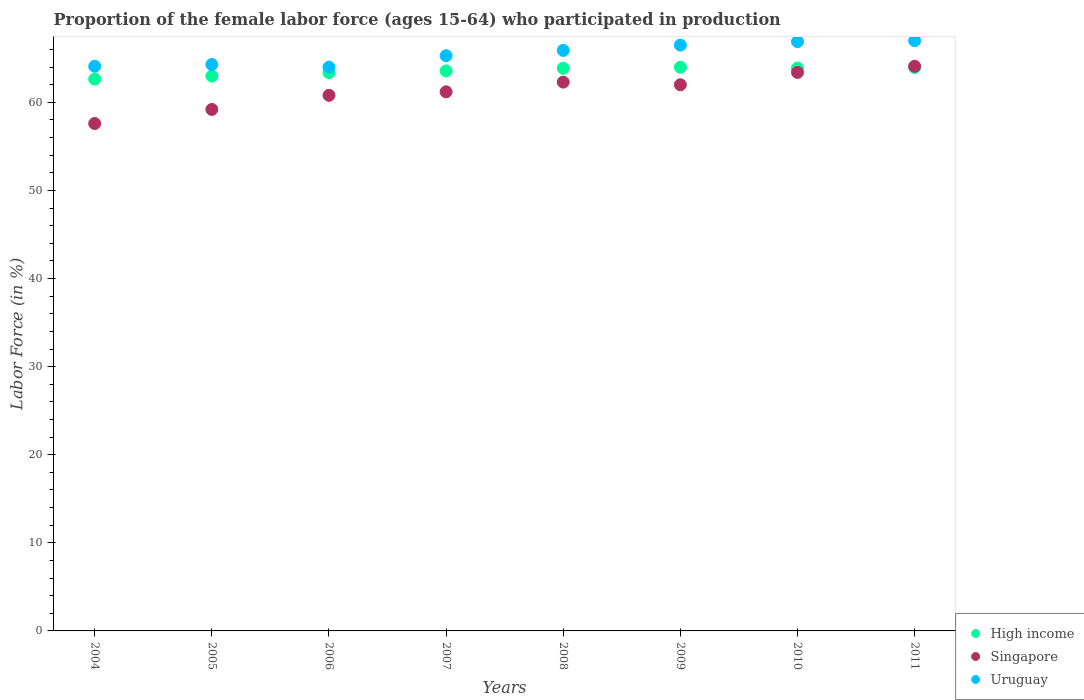Is the number of dotlines equal to the number of legend labels?
Ensure brevity in your answer.  Yes. What is the proportion of the female labor force who participated in production in High income in 2010?
Your response must be concise. 63.89. Across all years, what is the maximum proportion of the female labor force who participated in production in Singapore?
Keep it short and to the point. 64.1. Across all years, what is the minimum proportion of the female labor force who participated in production in High income?
Make the answer very short. 62.64. In which year was the proportion of the female labor force who participated in production in High income maximum?
Ensure brevity in your answer.  2009. What is the total proportion of the female labor force who participated in production in Singapore in the graph?
Offer a terse response. 490.6. What is the difference between the proportion of the female labor force who participated in production in Singapore in 2007 and that in 2010?
Keep it short and to the point. -2.2. What is the difference between the proportion of the female labor force who participated in production in High income in 2004 and the proportion of the female labor force who participated in production in Singapore in 2008?
Your response must be concise. 0.34. What is the average proportion of the female labor force who participated in production in High income per year?
Offer a terse response. 63.53. In the year 2006, what is the difference between the proportion of the female labor force who participated in production in High income and proportion of the female labor force who participated in production in Uruguay?
Your answer should be very brief. -0.62. In how many years, is the proportion of the female labor force who participated in production in Uruguay greater than 38 %?
Make the answer very short. 8. What is the ratio of the proportion of the female labor force who participated in production in Uruguay in 2005 to that in 2006?
Make the answer very short. 1. Is the difference between the proportion of the female labor force who participated in production in High income in 2006 and 2011 greater than the difference between the proportion of the female labor force who participated in production in Uruguay in 2006 and 2011?
Ensure brevity in your answer.  Yes. What is the difference between the highest and the second highest proportion of the female labor force who participated in production in Singapore?
Offer a terse response. 0.7. What is the difference between the highest and the lowest proportion of the female labor force who participated in production in High income?
Offer a terse response. 1.35. Is it the case that in every year, the sum of the proportion of the female labor force who participated in production in Uruguay and proportion of the female labor force who participated in production in Singapore  is greater than the proportion of the female labor force who participated in production in High income?
Your answer should be compact. Yes. Is the proportion of the female labor force who participated in production in Uruguay strictly greater than the proportion of the female labor force who participated in production in High income over the years?
Make the answer very short. Yes. How many years are there in the graph?
Offer a terse response. 8. Does the graph contain grids?
Your response must be concise. No. Where does the legend appear in the graph?
Provide a succinct answer. Bottom right. How many legend labels are there?
Provide a succinct answer. 3. How are the legend labels stacked?
Ensure brevity in your answer.  Vertical. What is the title of the graph?
Make the answer very short. Proportion of the female labor force (ages 15-64) who participated in production. Does "American Samoa" appear as one of the legend labels in the graph?
Provide a short and direct response. No. What is the label or title of the X-axis?
Your answer should be compact. Years. What is the Labor Force (in %) in High income in 2004?
Offer a terse response. 62.64. What is the Labor Force (in %) in Singapore in 2004?
Your answer should be compact. 57.6. What is the Labor Force (in %) of Uruguay in 2004?
Ensure brevity in your answer.  64.1. What is the Labor Force (in %) in High income in 2005?
Offer a terse response. 62.99. What is the Labor Force (in %) in Singapore in 2005?
Provide a succinct answer. 59.2. What is the Labor Force (in %) of Uruguay in 2005?
Offer a terse response. 64.3. What is the Labor Force (in %) of High income in 2006?
Your response must be concise. 63.38. What is the Labor Force (in %) of Singapore in 2006?
Your answer should be very brief. 60.8. What is the Labor Force (in %) of High income in 2007?
Provide a succinct answer. 63.57. What is the Labor Force (in %) in Singapore in 2007?
Provide a short and direct response. 61.2. What is the Labor Force (in %) of Uruguay in 2007?
Your answer should be very brief. 65.3. What is the Labor Force (in %) of High income in 2008?
Give a very brief answer. 63.87. What is the Labor Force (in %) of Singapore in 2008?
Keep it short and to the point. 62.3. What is the Labor Force (in %) of Uruguay in 2008?
Offer a very short reply. 65.9. What is the Labor Force (in %) in High income in 2009?
Ensure brevity in your answer.  63.99. What is the Labor Force (in %) of Uruguay in 2009?
Keep it short and to the point. 66.5. What is the Labor Force (in %) in High income in 2010?
Your response must be concise. 63.89. What is the Labor Force (in %) in Singapore in 2010?
Offer a very short reply. 63.4. What is the Labor Force (in %) of Uruguay in 2010?
Provide a short and direct response. 66.9. What is the Labor Force (in %) in High income in 2011?
Offer a very short reply. 63.95. What is the Labor Force (in %) of Singapore in 2011?
Your answer should be very brief. 64.1. What is the Labor Force (in %) of Uruguay in 2011?
Offer a very short reply. 67. Across all years, what is the maximum Labor Force (in %) in High income?
Your answer should be compact. 63.99. Across all years, what is the maximum Labor Force (in %) of Singapore?
Your response must be concise. 64.1. Across all years, what is the minimum Labor Force (in %) in High income?
Provide a succinct answer. 62.64. Across all years, what is the minimum Labor Force (in %) in Singapore?
Provide a succinct answer. 57.6. What is the total Labor Force (in %) in High income in the graph?
Your answer should be compact. 508.28. What is the total Labor Force (in %) of Singapore in the graph?
Give a very brief answer. 490.6. What is the total Labor Force (in %) in Uruguay in the graph?
Ensure brevity in your answer.  524. What is the difference between the Labor Force (in %) in High income in 2004 and that in 2005?
Offer a very short reply. -0.35. What is the difference between the Labor Force (in %) in Uruguay in 2004 and that in 2005?
Provide a succinct answer. -0.2. What is the difference between the Labor Force (in %) of High income in 2004 and that in 2006?
Make the answer very short. -0.74. What is the difference between the Labor Force (in %) in Uruguay in 2004 and that in 2006?
Offer a terse response. 0.1. What is the difference between the Labor Force (in %) in High income in 2004 and that in 2007?
Your answer should be very brief. -0.93. What is the difference between the Labor Force (in %) of Uruguay in 2004 and that in 2007?
Provide a succinct answer. -1.2. What is the difference between the Labor Force (in %) in High income in 2004 and that in 2008?
Your response must be concise. -1.23. What is the difference between the Labor Force (in %) of High income in 2004 and that in 2009?
Your answer should be compact. -1.35. What is the difference between the Labor Force (in %) in Singapore in 2004 and that in 2009?
Give a very brief answer. -4.4. What is the difference between the Labor Force (in %) in Uruguay in 2004 and that in 2009?
Your response must be concise. -2.4. What is the difference between the Labor Force (in %) of High income in 2004 and that in 2010?
Make the answer very short. -1.25. What is the difference between the Labor Force (in %) in High income in 2004 and that in 2011?
Ensure brevity in your answer.  -1.31. What is the difference between the Labor Force (in %) of Uruguay in 2004 and that in 2011?
Your answer should be compact. -2.9. What is the difference between the Labor Force (in %) of High income in 2005 and that in 2006?
Give a very brief answer. -0.4. What is the difference between the Labor Force (in %) in Uruguay in 2005 and that in 2006?
Your answer should be very brief. 0.3. What is the difference between the Labor Force (in %) in High income in 2005 and that in 2007?
Keep it short and to the point. -0.58. What is the difference between the Labor Force (in %) in Uruguay in 2005 and that in 2007?
Offer a terse response. -1. What is the difference between the Labor Force (in %) of High income in 2005 and that in 2008?
Your response must be concise. -0.88. What is the difference between the Labor Force (in %) of Uruguay in 2005 and that in 2008?
Ensure brevity in your answer.  -1.6. What is the difference between the Labor Force (in %) of High income in 2005 and that in 2009?
Your answer should be very brief. -1. What is the difference between the Labor Force (in %) in High income in 2005 and that in 2010?
Your answer should be very brief. -0.9. What is the difference between the Labor Force (in %) of High income in 2005 and that in 2011?
Provide a short and direct response. -0.97. What is the difference between the Labor Force (in %) in Uruguay in 2005 and that in 2011?
Give a very brief answer. -2.7. What is the difference between the Labor Force (in %) in High income in 2006 and that in 2007?
Your answer should be very brief. -0.19. What is the difference between the Labor Force (in %) of Singapore in 2006 and that in 2007?
Ensure brevity in your answer.  -0.4. What is the difference between the Labor Force (in %) in Uruguay in 2006 and that in 2007?
Your answer should be very brief. -1.3. What is the difference between the Labor Force (in %) in High income in 2006 and that in 2008?
Make the answer very short. -0.49. What is the difference between the Labor Force (in %) of Singapore in 2006 and that in 2008?
Make the answer very short. -1.5. What is the difference between the Labor Force (in %) in Uruguay in 2006 and that in 2008?
Offer a very short reply. -1.9. What is the difference between the Labor Force (in %) of High income in 2006 and that in 2009?
Offer a very short reply. -0.61. What is the difference between the Labor Force (in %) in Singapore in 2006 and that in 2009?
Provide a succinct answer. -1.2. What is the difference between the Labor Force (in %) of Uruguay in 2006 and that in 2009?
Your answer should be very brief. -2.5. What is the difference between the Labor Force (in %) in High income in 2006 and that in 2010?
Ensure brevity in your answer.  -0.51. What is the difference between the Labor Force (in %) in Singapore in 2006 and that in 2010?
Offer a terse response. -2.6. What is the difference between the Labor Force (in %) in High income in 2006 and that in 2011?
Your answer should be very brief. -0.57. What is the difference between the Labor Force (in %) in Uruguay in 2006 and that in 2011?
Offer a very short reply. -3. What is the difference between the Labor Force (in %) of High income in 2007 and that in 2008?
Ensure brevity in your answer.  -0.3. What is the difference between the Labor Force (in %) of Uruguay in 2007 and that in 2008?
Offer a terse response. -0.6. What is the difference between the Labor Force (in %) in High income in 2007 and that in 2009?
Keep it short and to the point. -0.42. What is the difference between the Labor Force (in %) of Singapore in 2007 and that in 2009?
Ensure brevity in your answer.  -0.8. What is the difference between the Labor Force (in %) of High income in 2007 and that in 2010?
Keep it short and to the point. -0.32. What is the difference between the Labor Force (in %) in High income in 2007 and that in 2011?
Keep it short and to the point. -0.38. What is the difference between the Labor Force (in %) of Uruguay in 2007 and that in 2011?
Keep it short and to the point. -1.7. What is the difference between the Labor Force (in %) of High income in 2008 and that in 2009?
Your answer should be very brief. -0.12. What is the difference between the Labor Force (in %) in Singapore in 2008 and that in 2009?
Offer a very short reply. 0.3. What is the difference between the Labor Force (in %) of High income in 2008 and that in 2010?
Your answer should be very brief. -0.02. What is the difference between the Labor Force (in %) in Uruguay in 2008 and that in 2010?
Offer a terse response. -1. What is the difference between the Labor Force (in %) in High income in 2008 and that in 2011?
Keep it short and to the point. -0.09. What is the difference between the Labor Force (in %) of Singapore in 2008 and that in 2011?
Keep it short and to the point. -1.8. What is the difference between the Labor Force (in %) in Uruguay in 2008 and that in 2011?
Provide a short and direct response. -1.1. What is the difference between the Labor Force (in %) in High income in 2009 and that in 2010?
Offer a terse response. 0.1. What is the difference between the Labor Force (in %) in Singapore in 2009 and that in 2010?
Give a very brief answer. -1.4. What is the difference between the Labor Force (in %) of High income in 2009 and that in 2011?
Provide a succinct answer. 0.04. What is the difference between the Labor Force (in %) of Singapore in 2009 and that in 2011?
Give a very brief answer. -2.1. What is the difference between the Labor Force (in %) in Uruguay in 2009 and that in 2011?
Your answer should be very brief. -0.5. What is the difference between the Labor Force (in %) of High income in 2010 and that in 2011?
Your response must be concise. -0.06. What is the difference between the Labor Force (in %) in Uruguay in 2010 and that in 2011?
Offer a terse response. -0.1. What is the difference between the Labor Force (in %) in High income in 2004 and the Labor Force (in %) in Singapore in 2005?
Provide a succinct answer. 3.44. What is the difference between the Labor Force (in %) in High income in 2004 and the Labor Force (in %) in Uruguay in 2005?
Provide a short and direct response. -1.66. What is the difference between the Labor Force (in %) of High income in 2004 and the Labor Force (in %) of Singapore in 2006?
Give a very brief answer. 1.84. What is the difference between the Labor Force (in %) of High income in 2004 and the Labor Force (in %) of Uruguay in 2006?
Provide a short and direct response. -1.36. What is the difference between the Labor Force (in %) in Singapore in 2004 and the Labor Force (in %) in Uruguay in 2006?
Provide a short and direct response. -6.4. What is the difference between the Labor Force (in %) in High income in 2004 and the Labor Force (in %) in Singapore in 2007?
Give a very brief answer. 1.44. What is the difference between the Labor Force (in %) in High income in 2004 and the Labor Force (in %) in Uruguay in 2007?
Keep it short and to the point. -2.66. What is the difference between the Labor Force (in %) of Singapore in 2004 and the Labor Force (in %) of Uruguay in 2007?
Offer a terse response. -7.7. What is the difference between the Labor Force (in %) of High income in 2004 and the Labor Force (in %) of Singapore in 2008?
Keep it short and to the point. 0.34. What is the difference between the Labor Force (in %) in High income in 2004 and the Labor Force (in %) in Uruguay in 2008?
Offer a very short reply. -3.26. What is the difference between the Labor Force (in %) of Singapore in 2004 and the Labor Force (in %) of Uruguay in 2008?
Your answer should be very brief. -8.3. What is the difference between the Labor Force (in %) in High income in 2004 and the Labor Force (in %) in Singapore in 2009?
Ensure brevity in your answer.  0.64. What is the difference between the Labor Force (in %) in High income in 2004 and the Labor Force (in %) in Uruguay in 2009?
Provide a short and direct response. -3.86. What is the difference between the Labor Force (in %) of Singapore in 2004 and the Labor Force (in %) of Uruguay in 2009?
Give a very brief answer. -8.9. What is the difference between the Labor Force (in %) in High income in 2004 and the Labor Force (in %) in Singapore in 2010?
Make the answer very short. -0.76. What is the difference between the Labor Force (in %) in High income in 2004 and the Labor Force (in %) in Uruguay in 2010?
Offer a terse response. -4.26. What is the difference between the Labor Force (in %) of High income in 2004 and the Labor Force (in %) of Singapore in 2011?
Offer a terse response. -1.46. What is the difference between the Labor Force (in %) of High income in 2004 and the Labor Force (in %) of Uruguay in 2011?
Ensure brevity in your answer.  -4.36. What is the difference between the Labor Force (in %) in Singapore in 2004 and the Labor Force (in %) in Uruguay in 2011?
Offer a very short reply. -9.4. What is the difference between the Labor Force (in %) of High income in 2005 and the Labor Force (in %) of Singapore in 2006?
Your answer should be compact. 2.19. What is the difference between the Labor Force (in %) of High income in 2005 and the Labor Force (in %) of Uruguay in 2006?
Make the answer very short. -1.01. What is the difference between the Labor Force (in %) in High income in 2005 and the Labor Force (in %) in Singapore in 2007?
Give a very brief answer. 1.79. What is the difference between the Labor Force (in %) in High income in 2005 and the Labor Force (in %) in Uruguay in 2007?
Provide a short and direct response. -2.31. What is the difference between the Labor Force (in %) in Singapore in 2005 and the Labor Force (in %) in Uruguay in 2007?
Provide a succinct answer. -6.1. What is the difference between the Labor Force (in %) in High income in 2005 and the Labor Force (in %) in Singapore in 2008?
Offer a terse response. 0.69. What is the difference between the Labor Force (in %) of High income in 2005 and the Labor Force (in %) of Uruguay in 2008?
Provide a short and direct response. -2.91. What is the difference between the Labor Force (in %) in High income in 2005 and the Labor Force (in %) in Uruguay in 2009?
Give a very brief answer. -3.51. What is the difference between the Labor Force (in %) of High income in 2005 and the Labor Force (in %) of Singapore in 2010?
Your answer should be very brief. -0.41. What is the difference between the Labor Force (in %) in High income in 2005 and the Labor Force (in %) in Uruguay in 2010?
Provide a succinct answer. -3.91. What is the difference between the Labor Force (in %) of Singapore in 2005 and the Labor Force (in %) of Uruguay in 2010?
Give a very brief answer. -7.7. What is the difference between the Labor Force (in %) in High income in 2005 and the Labor Force (in %) in Singapore in 2011?
Make the answer very short. -1.11. What is the difference between the Labor Force (in %) of High income in 2005 and the Labor Force (in %) of Uruguay in 2011?
Your answer should be compact. -4.01. What is the difference between the Labor Force (in %) in High income in 2006 and the Labor Force (in %) in Singapore in 2007?
Your response must be concise. 2.18. What is the difference between the Labor Force (in %) in High income in 2006 and the Labor Force (in %) in Uruguay in 2007?
Your answer should be very brief. -1.92. What is the difference between the Labor Force (in %) in Singapore in 2006 and the Labor Force (in %) in Uruguay in 2007?
Give a very brief answer. -4.5. What is the difference between the Labor Force (in %) in High income in 2006 and the Labor Force (in %) in Singapore in 2008?
Provide a short and direct response. 1.08. What is the difference between the Labor Force (in %) in High income in 2006 and the Labor Force (in %) in Uruguay in 2008?
Make the answer very short. -2.52. What is the difference between the Labor Force (in %) of Singapore in 2006 and the Labor Force (in %) of Uruguay in 2008?
Your response must be concise. -5.1. What is the difference between the Labor Force (in %) in High income in 2006 and the Labor Force (in %) in Singapore in 2009?
Make the answer very short. 1.38. What is the difference between the Labor Force (in %) of High income in 2006 and the Labor Force (in %) of Uruguay in 2009?
Your answer should be very brief. -3.12. What is the difference between the Labor Force (in %) of High income in 2006 and the Labor Force (in %) of Singapore in 2010?
Your answer should be very brief. -0.02. What is the difference between the Labor Force (in %) in High income in 2006 and the Labor Force (in %) in Uruguay in 2010?
Provide a short and direct response. -3.52. What is the difference between the Labor Force (in %) in High income in 2006 and the Labor Force (in %) in Singapore in 2011?
Ensure brevity in your answer.  -0.72. What is the difference between the Labor Force (in %) of High income in 2006 and the Labor Force (in %) of Uruguay in 2011?
Your answer should be very brief. -3.62. What is the difference between the Labor Force (in %) in Singapore in 2006 and the Labor Force (in %) in Uruguay in 2011?
Your answer should be compact. -6.2. What is the difference between the Labor Force (in %) in High income in 2007 and the Labor Force (in %) in Singapore in 2008?
Provide a short and direct response. 1.27. What is the difference between the Labor Force (in %) in High income in 2007 and the Labor Force (in %) in Uruguay in 2008?
Offer a terse response. -2.33. What is the difference between the Labor Force (in %) of Singapore in 2007 and the Labor Force (in %) of Uruguay in 2008?
Your answer should be compact. -4.7. What is the difference between the Labor Force (in %) of High income in 2007 and the Labor Force (in %) of Singapore in 2009?
Your answer should be very brief. 1.57. What is the difference between the Labor Force (in %) of High income in 2007 and the Labor Force (in %) of Uruguay in 2009?
Provide a short and direct response. -2.93. What is the difference between the Labor Force (in %) in High income in 2007 and the Labor Force (in %) in Singapore in 2010?
Your answer should be very brief. 0.17. What is the difference between the Labor Force (in %) in High income in 2007 and the Labor Force (in %) in Uruguay in 2010?
Provide a succinct answer. -3.33. What is the difference between the Labor Force (in %) of Singapore in 2007 and the Labor Force (in %) of Uruguay in 2010?
Your answer should be compact. -5.7. What is the difference between the Labor Force (in %) of High income in 2007 and the Labor Force (in %) of Singapore in 2011?
Give a very brief answer. -0.53. What is the difference between the Labor Force (in %) of High income in 2007 and the Labor Force (in %) of Uruguay in 2011?
Offer a very short reply. -3.43. What is the difference between the Labor Force (in %) of High income in 2008 and the Labor Force (in %) of Singapore in 2009?
Make the answer very short. 1.87. What is the difference between the Labor Force (in %) of High income in 2008 and the Labor Force (in %) of Uruguay in 2009?
Give a very brief answer. -2.63. What is the difference between the Labor Force (in %) of Singapore in 2008 and the Labor Force (in %) of Uruguay in 2009?
Keep it short and to the point. -4.2. What is the difference between the Labor Force (in %) of High income in 2008 and the Labor Force (in %) of Singapore in 2010?
Offer a very short reply. 0.47. What is the difference between the Labor Force (in %) of High income in 2008 and the Labor Force (in %) of Uruguay in 2010?
Give a very brief answer. -3.03. What is the difference between the Labor Force (in %) in Singapore in 2008 and the Labor Force (in %) in Uruguay in 2010?
Your response must be concise. -4.6. What is the difference between the Labor Force (in %) of High income in 2008 and the Labor Force (in %) of Singapore in 2011?
Keep it short and to the point. -0.23. What is the difference between the Labor Force (in %) of High income in 2008 and the Labor Force (in %) of Uruguay in 2011?
Provide a succinct answer. -3.13. What is the difference between the Labor Force (in %) of Singapore in 2008 and the Labor Force (in %) of Uruguay in 2011?
Provide a short and direct response. -4.7. What is the difference between the Labor Force (in %) of High income in 2009 and the Labor Force (in %) of Singapore in 2010?
Offer a very short reply. 0.59. What is the difference between the Labor Force (in %) of High income in 2009 and the Labor Force (in %) of Uruguay in 2010?
Your answer should be very brief. -2.91. What is the difference between the Labor Force (in %) in Singapore in 2009 and the Labor Force (in %) in Uruguay in 2010?
Keep it short and to the point. -4.9. What is the difference between the Labor Force (in %) in High income in 2009 and the Labor Force (in %) in Singapore in 2011?
Your answer should be very brief. -0.11. What is the difference between the Labor Force (in %) in High income in 2009 and the Labor Force (in %) in Uruguay in 2011?
Offer a very short reply. -3.01. What is the difference between the Labor Force (in %) in High income in 2010 and the Labor Force (in %) in Singapore in 2011?
Your answer should be very brief. -0.21. What is the difference between the Labor Force (in %) of High income in 2010 and the Labor Force (in %) of Uruguay in 2011?
Provide a succinct answer. -3.11. What is the average Labor Force (in %) in High income per year?
Provide a short and direct response. 63.53. What is the average Labor Force (in %) in Singapore per year?
Provide a short and direct response. 61.33. What is the average Labor Force (in %) of Uruguay per year?
Keep it short and to the point. 65.5. In the year 2004, what is the difference between the Labor Force (in %) in High income and Labor Force (in %) in Singapore?
Ensure brevity in your answer.  5.04. In the year 2004, what is the difference between the Labor Force (in %) in High income and Labor Force (in %) in Uruguay?
Offer a very short reply. -1.46. In the year 2004, what is the difference between the Labor Force (in %) of Singapore and Labor Force (in %) of Uruguay?
Offer a terse response. -6.5. In the year 2005, what is the difference between the Labor Force (in %) in High income and Labor Force (in %) in Singapore?
Your answer should be compact. 3.79. In the year 2005, what is the difference between the Labor Force (in %) in High income and Labor Force (in %) in Uruguay?
Make the answer very short. -1.31. In the year 2005, what is the difference between the Labor Force (in %) of Singapore and Labor Force (in %) of Uruguay?
Provide a succinct answer. -5.1. In the year 2006, what is the difference between the Labor Force (in %) in High income and Labor Force (in %) in Singapore?
Your response must be concise. 2.58. In the year 2006, what is the difference between the Labor Force (in %) in High income and Labor Force (in %) in Uruguay?
Your response must be concise. -0.62. In the year 2007, what is the difference between the Labor Force (in %) in High income and Labor Force (in %) in Singapore?
Your answer should be compact. 2.37. In the year 2007, what is the difference between the Labor Force (in %) of High income and Labor Force (in %) of Uruguay?
Your answer should be very brief. -1.73. In the year 2007, what is the difference between the Labor Force (in %) of Singapore and Labor Force (in %) of Uruguay?
Your answer should be very brief. -4.1. In the year 2008, what is the difference between the Labor Force (in %) in High income and Labor Force (in %) in Singapore?
Make the answer very short. 1.57. In the year 2008, what is the difference between the Labor Force (in %) in High income and Labor Force (in %) in Uruguay?
Offer a very short reply. -2.03. In the year 2008, what is the difference between the Labor Force (in %) in Singapore and Labor Force (in %) in Uruguay?
Your response must be concise. -3.6. In the year 2009, what is the difference between the Labor Force (in %) of High income and Labor Force (in %) of Singapore?
Keep it short and to the point. 1.99. In the year 2009, what is the difference between the Labor Force (in %) in High income and Labor Force (in %) in Uruguay?
Your answer should be very brief. -2.51. In the year 2009, what is the difference between the Labor Force (in %) of Singapore and Labor Force (in %) of Uruguay?
Make the answer very short. -4.5. In the year 2010, what is the difference between the Labor Force (in %) in High income and Labor Force (in %) in Singapore?
Provide a short and direct response. 0.49. In the year 2010, what is the difference between the Labor Force (in %) of High income and Labor Force (in %) of Uruguay?
Ensure brevity in your answer.  -3.01. In the year 2011, what is the difference between the Labor Force (in %) in High income and Labor Force (in %) in Singapore?
Your answer should be very brief. -0.15. In the year 2011, what is the difference between the Labor Force (in %) of High income and Labor Force (in %) of Uruguay?
Your answer should be very brief. -3.05. What is the ratio of the Labor Force (in %) in Singapore in 2004 to that in 2005?
Your answer should be compact. 0.97. What is the ratio of the Labor Force (in %) of High income in 2004 to that in 2006?
Your response must be concise. 0.99. What is the ratio of the Labor Force (in %) in Uruguay in 2004 to that in 2006?
Offer a terse response. 1. What is the ratio of the Labor Force (in %) in High income in 2004 to that in 2007?
Keep it short and to the point. 0.99. What is the ratio of the Labor Force (in %) in Singapore in 2004 to that in 2007?
Your answer should be compact. 0.94. What is the ratio of the Labor Force (in %) of Uruguay in 2004 to that in 2007?
Make the answer very short. 0.98. What is the ratio of the Labor Force (in %) in High income in 2004 to that in 2008?
Keep it short and to the point. 0.98. What is the ratio of the Labor Force (in %) of Singapore in 2004 to that in 2008?
Ensure brevity in your answer.  0.92. What is the ratio of the Labor Force (in %) in Uruguay in 2004 to that in 2008?
Your answer should be compact. 0.97. What is the ratio of the Labor Force (in %) of High income in 2004 to that in 2009?
Provide a succinct answer. 0.98. What is the ratio of the Labor Force (in %) in Singapore in 2004 to that in 2009?
Offer a terse response. 0.93. What is the ratio of the Labor Force (in %) in Uruguay in 2004 to that in 2009?
Give a very brief answer. 0.96. What is the ratio of the Labor Force (in %) in High income in 2004 to that in 2010?
Ensure brevity in your answer.  0.98. What is the ratio of the Labor Force (in %) in Singapore in 2004 to that in 2010?
Offer a terse response. 0.91. What is the ratio of the Labor Force (in %) in Uruguay in 2004 to that in 2010?
Ensure brevity in your answer.  0.96. What is the ratio of the Labor Force (in %) in High income in 2004 to that in 2011?
Your answer should be very brief. 0.98. What is the ratio of the Labor Force (in %) in Singapore in 2004 to that in 2011?
Your response must be concise. 0.9. What is the ratio of the Labor Force (in %) in Uruguay in 2004 to that in 2011?
Give a very brief answer. 0.96. What is the ratio of the Labor Force (in %) of High income in 2005 to that in 2006?
Offer a very short reply. 0.99. What is the ratio of the Labor Force (in %) of Singapore in 2005 to that in 2006?
Your answer should be very brief. 0.97. What is the ratio of the Labor Force (in %) of High income in 2005 to that in 2007?
Give a very brief answer. 0.99. What is the ratio of the Labor Force (in %) of Singapore in 2005 to that in 2007?
Give a very brief answer. 0.97. What is the ratio of the Labor Force (in %) of Uruguay in 2005 to that in 2007?
Offer a terse response. 0.98. What is the ratio of the Labor Force (in %) of High income in 2005 to that in 2008?
Provide a short and direct response. 0.99. What is the ratio of the Labor Force (in %) of Singapore in 2005 to that in 2008?
Give a very brief answer. 0.95. What is the ratio of the Labor Force (in %) of Uruguay in 2005 to that in 2008?
Keep it short and to the point. 0.98. What is the ratio of the Labor Force (in %) in High income in 2005 to that in 2009?
Make the answer very short. 0.98. What is the ratio of the Labor Force (in %) in Singapore in 2005 to that in 2009?
Your response must be concise. 0.95. What is the ratio of the Labor Force (in %) in Uruguay in 2005 to that in 2009?
Give a very brief answer. 0.97. What is the ratio of the Labor Force (in %) in High income in 2005 to that in 2010?
Provide a short and direct response. 0.99. What is the ratio of the Labor Force (in %) of Singapore in 2005 to that in 2010?
Your answer should be very brief. 0.93. What is the ratio of the Labor Force (in %) in Uruguay in 2005 to that in 2010?
Give a very brief answer. 0.96. What is the ratio of the Labor Force (in %) in High income in 2005 to that in 2011?
Your answer should be very brief. 0.98. What is the ratio of the Labor Force (in %) in Singapore in 2005 to that in 2011?
Make the answer very short. 0.92. What is the ratio of the Labor Force (in %) of Uruguay in 2005 to that in 2011?
Give a very brief answer. 0.96. What is the ratio of the Labor Force (in %) of High income in 2006 to that in 2007?
Keep it short and to the point. 1. What is the ratio of the Labor Force (in %) of Uruguay in 2006 to that in 2007?
Provide a succinct answer. 0.98. What is the ratio of the Labor Force (in %) of Singapore in 2006 to that in 2008?
Give a very brief answer. 0.98. What is the ratio of the Labor Force (in %) of Uruguay in 2006 to that in 2008?
Your answer should be compact. 0.97. What is the ratio of the Labor Force (in %) of Singapore in 2006 to that in 2009?
Provide a succinct answer. 0.98. What is the ratio of the Labor Force (in %) in Uruguay in 2006 to that in 2009?
Your response must be concise. 0.96. What is the ratio of the Labor Force (in %) of Uruguay in 2006 to that in 2010?
Make the answer very short. 0.96. What is the ratio of the Labor Force (in %) in High income in 2006 to that in 2011?
Provide a succinct answer. 0.99. What is the ratio of the Labor Force (in %) of Singapore in 2006 to that in 2011?
Your response must be concise. 0.95. What is the ratio of the Labor Force (in %) of Uruguay in 2006 to that in 2011?
Your answer should be very brief. 0.96. What is the ratio of the Labor Force (in %) in Singapore in 2007 to that in 2008?
Offer a very short reply. 0.98. What is the ratio of the Labor Force (in %) in Uruguay in 2007 to that in 2008?
Offer a very short reply. 0.99. What is the ratio of the Labor Force (in %) of Singapore in 2007 to that in 2009?
Give a very brief answer. 0.99. What is the ratio of the Labor Force (in %) of Singapore in 2007 to that in 2010?
Offer a terse response. 0.97. What is the ratio of the Labor Force (in %) in Uruguay in 2007 to that in 2010?
Provide a succinct answer. 0.98. What is the ratio of the Labor Force (in %) in Singapore in 2007 to that in 2011?
Your response must be concise. 0.95. What is the ratio of the Labor Force (in %) in Uruguay in 2007 to that in 2011?
Offer a terse response. 0.97. What is the ratio of the Labor Force (in %) of Singapore in 2008 to that in 2009?
Give a very brief answer. 1. What is the ratio of the Labor Force (in %) in Singapore in 2008 to that in 2010?
Make the answer very short. 0.98. What is the ratio of the Labor Force (in %) in Uruguay in 2008 to that in 2010?
Your answer should be very brief. 0.99. What is the ratio of the Labor Force (in %) in Singapore in 2008 to that in 2011?
Offer a terse response. 0.97. What is the ratio of the Labor Force (in %) of Uruguay in 2008 to that in 2011?
Your response must be concise. 0.98. What is the ratio of the Labor Force (in %) of Singapore in 2009 to that in 2010?
Give a very brief answer. 0.98. What is the ratio of the Labor Force (in %) in Singapore in 2009 to that in 2011?
Your response must be concise. 0.97. What is the ratio of the Labor Force (in %) in Uruguay in 2009 to that in 2011?
Give a very brief answer. 0.99. What is the ratio of the Labor Force (in %) in Singapore in 2010 to that in 2011?
Offer a terse response. 0.99. What is the ratio of the Labor Force (in %) in Uruguay in 2010 to that in 2011?
Your answer should be very brief. 1. What is the difference between the highest and the second highest Labor Force (in %) of High income?
Offer a very short reply. 0.04. What is the difference between the highest and the second highest Labor Force (in %) in Singapore?
Ensure brevity in your answer.  0.7. What is the difference between the highest and the lowest Labor Force (in %) in High income?
Offer a terse response. 1.35. What is the difference between the highest and the lowest Labor Force (in %) in Uruguay?
Your response must be concise. 3. 